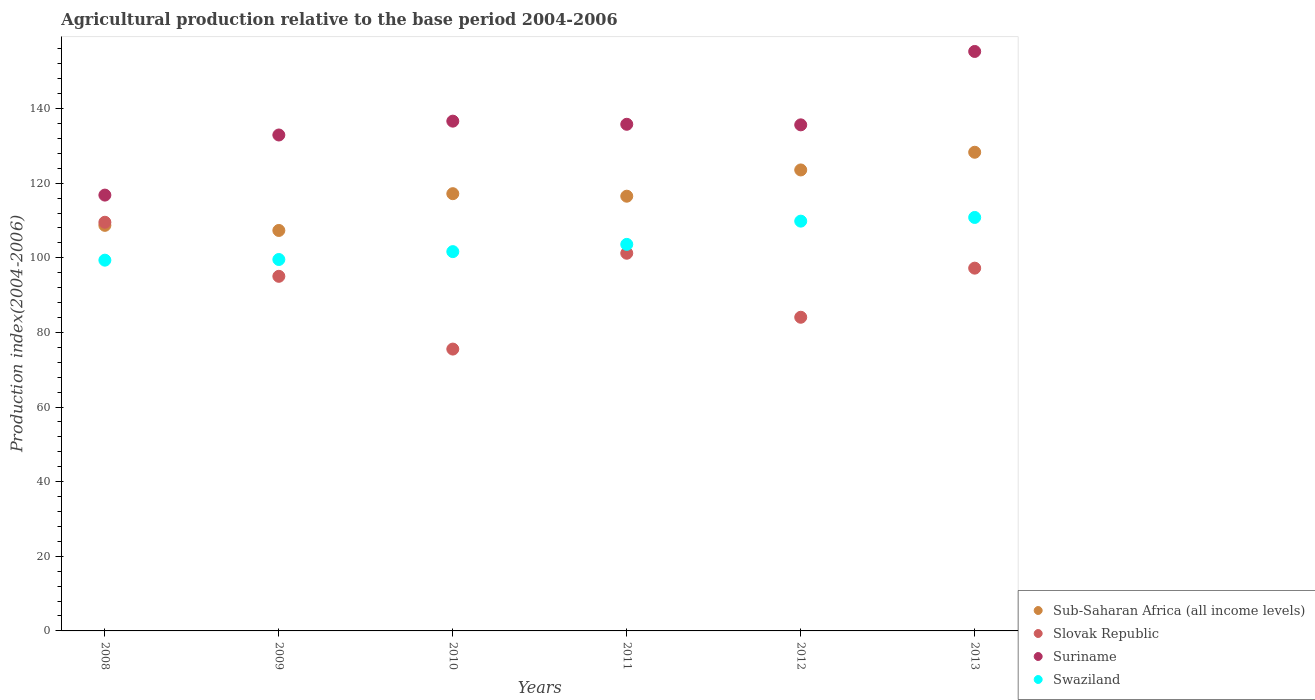How many different coloured dotlines are there?
Provide a succinct answer. 4. What is the agricultural production index in Sub-Saharan Africa (all income levels) in 2011?
Ensure brevity in your answer.  116.52. Across all years, what is the maximum agricultural production index in Slovak Republic?
Your answer should be compact. 109.53. Across all years, what is the minimum agricultural production index in Slovak Republic?
Offer a very short reply. 75.54. What is the total agricultural production index in Swaziland in the graph?
Keep it short and to the point. 624.83. What is the difference between the agricultural production index in Suriname in 2012 and that in 2013?
Make the answer very short. -19.67. What is the difference between the agricultural production index in Sub-Saharan Africa (all income levels) in 2010 and the agricultural production index in Swaziland in 2009?
Offer a terse response. 17.64. What is the average agricultural production index in Swaziland per year?
Make the answer very short. 104.14. In the year 2010, what is the difference between the agricultural production index in Slovak Republic and agricultural production index in Suriname?
Provide a succinct answer. -61.09. In how many years, is the agricultural production index in Suriname greater than 32?
Provide a succinct answer. 6. What is the ratio of the agricultural production index in Sub-Saharan Africa (all income levels) in 2009 to that in 2012?
Provide a succinct answer. 0.87. Is the difference between the agricultural production index in Slovak Republic in 2011 and 2012 greater than the difference between the agricultural production index in Suriname in 2011 and 2012?
Make the answer very short. Yes. What is the difference between the highest and the second highest agricultural production index in Slovak Republic?
Keep it short and to the point. 8.3. What is the difference between the highest and the lowest agricultural production index in Suriname?
Give a very brief answer. 38.5. In how many years, is the agricultural production index in Swaziland greater than the average agricultural production index in Swaziland taken over all years?
Offer a very short reply. 2. Is the sum of the agricultural production index in Suriname in 2008 and 2009 greater than the maximum agricultural production index in Sub-Saharan Africa (all income levels) across all years?
Provide a short and direct response. Yes. Does the agricultural production index in Slovak Republic monotonically increase over the years?
Ensure brevity in your answer.  No. How many dotlines are there?
Your answer should be compact. 4. What is the difference between two consecutive major ticks on the Y-axis?
Provide a succinct answer. 20. Are the values on the major ticks of Y-axis written in scientific E-notation?
Give a very brief answer. No. Does the graph contain any zero values?
Offer a terse response. No. Does the graph contain grids?
Your response must be concise. No. Where does the legend appear in the graph?
Offer a terse response. Bottom right. What is the title of the graph?
Provide a succinct answer. Agricultural production relative to the base period 2004-2006. Does "Saudi Arabia" appear as one of the legend labels in the graph?
Keep it short and to the point. No. What is the label or title of the X-axis?
Make the answer very short. Years. What is the label or title of the Y-axis?
Your answer should be compact. Production index(2004-2006). What is the Production index(2004-2006) in Sub-Saharan Africa (all income levels) in 2008?
Your answer should be very brief. 108.7. What is the Production index(2004-2006) of Slovak Republic in 2008?
Provide a succinct answer. 109.53. What is the Production index(2004-2006) of Suriname in 2008?
Provide a succinct answer. 116.81. What is the Production index(2004-2006) of Swaziland in 2008?
Your response must be concise. 99.37. What is the Production index(2004-2006) in Sub-Saharan Africa (all income levels) in 2009?
Make the answer very short. 107.33. What is the Production index(2004-2006) in Slovak Republic in 2009?
Your answer should be compact. 95.04. What is the Production index(2004-2006) of Suriname in 2009?
Keep it short and to the point. 132.92. What is the Production index(2004-2006) of Swaziland in 2009?
Offer a terse response. 99.55. What is the Production index(2004-2006) of Sub-Saharan Africa (all income levels) in 2010?
Offer a very short reply. 117.19. What is the Production index(2004-2006) of Slovak Republic in 2010?
Your answer should be compact. 75.54. What is the Production index(2004-2006) in Suriname in 2010?
Offer a very short reply. 136.63. What is the Production index(2004-2006) of Swaziland in 2010?
Offer a terse response. 101.66. What is the Production index(2004-2006) of Sub-Saharan Africa (all income levels) in 2011?
Keep it short and to the point. 116.52. What is the Production index(2004-2006) of Slovak Republic in 2011?
Offer a very short reply. 101.23. What is the Production index(2004-2006) in Suriname in 2011?
Your answer should be compact. 135.79. What is the Production index(2004-2006) in Swaziland in 2011?
Provide a short and direct response. 103.6. What is the Production index(2004-2006) of Sub-Saharan Africa (all income levels) in 2012?
Ensure brevity in your answer.  123.55. What is the Production index(2004-2006) in Slovak Republic in 2012?
Your answer should be compact. 84.07. What is the Production index(2004-2006) in Suriname in 2012?
Your response must be concise. 135.64. What is the Production index(2004-2006) in Swaziland in 2012?
Offer a very short reply. 109.83. What is the Production index(2004-2006) of Sub-Saharan Africa (all income levels) in 2013?
Your answer should be compact. 128.29. What is the Production index(2004-2006) in Slovak Republic in 2013?
Offer a terse response. 97.23. What is the Production index(2004-2006) of Suriname in 2013?
Keep it short and to the point. 155.31. What is the Production index(2004-2006) of Swaziland in 2013?
Provide a short and direct response. 110.82. Across all years, what is the maximum Production index(2004-2006) in Sub-Saharan Africa (all income levels)?
Provide a succinct answer. 128.29. Across all years, what is the maximum Production index(2004-2006) of Slovak Republic?
Make the answer very short. 109.53. Across all years, what is the maximum Production index(2004-2006) of Suriname?
Provide a short and direct response. 155.31. Across all years, what is the maximum Production index(2004-2006) in Swaziland?
Provide a succinct answer. 110.82. Across all years, what is the minimum Production index(2004-2006) of Sub-Saharan Africa (all income levels)?
Offer a terse response. 107.33. Across all years, what is the minimum Production index(2004-2006) in Slovak Republic?
Your answer should be compact. 75.54. Across all years, what is the minimum Production index(2004-2006) of Suriname?
Your response must be concise. 116.81. Across all years, what is the minimum Production index(2004-2006) in Swaziland?
Offer a terse response. 99.37. What is the total Production index(2004-2006) in Sub-Saharan Africa (all income levels) in the graph?
Your answer should be compact. 701.59. What is the total Production index(2004-2006) in Slovak Republic in the graph?
Your response must be concise. 562.64. What is the total Production index(2004-2006) in Suriname in the graph?
Give a very brief answer. 813.1. What is the total Production index(2004-2006) in Swaziland in the graph?
Offer a terse response. 624.83. What is the difference between the Production index(2004-2006) of Sub-Saharan Africa (all income levels) in 2008 and that in 2009?
Your answer should be very brief. 1.37. What is the difference between the Production index(2004-2006) in Slovak Republic in 2008 and that in 2009?
Offer a terse response. 14.49. What is the difference between the Production index(2004-2006) of Suriname in 2008 and that in 2009?
Your response must be concise. -16.11. What is the difference between the Production index(2004-2006) in Swaziland in 2008 and that in 2009?
Provide a succinct answer. -0.18. What is the difference between the Production index(2004-2006) of Sub-Saharan Africa (all income levels) in 2008 and that in 2010?
Your answer should be compact. -8.49. What is the difference between the Production index(2004-2006) of Slovak Republic in 2008 and that in 2010?
Provide a succinct answer. 33.99. What is the difference between the Production index(2004-2006) of Suriname in 2008 and that in 2010?
Give a very brief answer. -19.82. What is the difference between the Production index(2004-2006) in Swaziland in 2008 and that in 2010?
Offer a very short reply. -2.29. What is the difference between the Production index(2004-2006) in Sub-Saharan Africa (all income levels) in 2008 and that in 2011?
Your answer should be very brief. -7.81. What is the difference between the Production index(2004-2006) of Suriname in 2008 and that in 2011?
Your answer should be very brief. -18.98. What is the difference between the Production index(2004-2006) of Swaziland in 2008 and that in 2011?
Keep it short and to the point. -4.23. What is the difference between the Production index(2004-2006) of Sub-Saharan Africa (all income levels) in 2008 and that in 2012?
Your response must be concise. -14.85. What is the difference between the Production index(2004-2006) in Slovak Republic in 2008 and that in 2012?
Your answer should be compact. 25.46. What is the difference between the Production index(2004-2006) in Suriname in 2008 and that in 2012?
Provide a succinct answer. -18.83. What is the difference between the Production index(2004-2006) of Swaziland in 2008 and that in 2012?
Make the answer very short. -10.46. What is the difference between the Production index(2004-2006) in Sub-Saharan Africa (all income levels) in 2008 and that in 2013?
Offer a very short reply. -19.59. What is the difference between the Production index(2004-2006) of Slovak Republic in 2008 and that in 2013?
Offer a terse response. 12.3. What is the difference between the Production index(2004-2006) in Suriname in 2008 and that in 2013?
Keep it short and to the point. -38.5. What is the difference between the Production index(2004-2006) in Swaziland in 2008 and that in 2013?
Make the answer very short. -11.45. What is the difference between the Production index(2004-2006) of Sub-Saharan Africa (all income levels) in 2009 and that in 2010?
Ensure brevity in your answer.  -9.86. What is the difference between the Production index(2004-2006) in Slovak Republic in 2009 and that in 2010?
Keep it short and to the point. 19.5. What is the difference between the Production index(2004-2006) in Suriname in 2009 and that in 2010?
Offer a very short reply. -3.71. What is the difference between the Production index(2004-2006) in Swaziland in 2009 and that in 2010?
Provide a short and direct response. -2.11. What is the difference between the Production index(2004-2006) in Sub-Saharan Africa (all income levels) in 2009 and that in 2011?
Your answer should be compact. -9.18. What is the difference between the Production index(2004-2006) of Slovak Republic in 2009 and that in 2011?
Provide a short and direct response. -6.19. What is the difference between the Production index(2004-2006) in Suriname in 2009 and that in 2011?
Your answer should be very brief. -2.87. What is the difference between the Production index(2004-2006) of Swaziland in 2009 and that in 2011?
Offer a very short reply. -4.05. What is the difference between the Production index(2004-2006) in Sub-Saharan Africa (all income levels) in 2009 and that in 2012?
Your response must be concise. -16.22. What is the difference between the Production index(2004-2006) in Slovak Republic in 2009 and that in 2012?
Keep it short and to the point. 10.97. What is the difference between the Production index(2004-2006) in Suriname in 2009 and that in 2012?
Ensure brevity in your answer.  -2.72. What is the difference between the Production index(2004-2006) of Swaziland in 2009 and that in 2012?
Ensure brevity in your answer.  -10.28. What is the difference between the Production index(2004-2006) in Sub-Saharan Africa (all income levels) in 2009 and that in 2013?
Ensure brevity in your answer.  -20.96. What is the difference between the Production index(2004-2006) of Slovak Republic in 2009 and that in 2013?
Make the answer very short. -2.19. What is the difference between the Production index(2004-2006) of Suriname in 2009 and that in 2013?
Give a very brief answer. -22.39. What is the difference between the Production index(2004-2006) of Swaziland in 2009 and that in 2013?
Your answer should be compact. -11.27. What is the difference between the Production index(2004-2006) in Sub-Saharan Africa (all income levels) in 2010 and that in 2011?
Provide a succinct answer. 0.67. What is the difference between the Production index(2004-2006) of Slovak Republic in 2010 and that in 2011?
Offer a terse response. -25.69. What is the difference between the Production index(2004-2006) of Suriname in 2010 and that in 2011?
Make the answer very short. 0.84. What is the difference between the Production index(2004-2006) of Swaziland in 2010 and that in 2011?
Your response must be concise. -1.94. What is the difference between the Production index(2004-2006) in Sub-Saharan Africa (all income levels) in 2010 and that in 2012?
Ensure brevity in your answer.  -6.36. What is the difference between the Production index(2004-2006) in Slovak Republic in 2010 and that in 2012?
Provide a short and direct response. -8.53. What is the difference between the Production index(2004-2006) in Swaziland in 2010 and that in 2012?
Provide a succinct answer. -8.17. What is the difference between the Production index(2004-2006) in Sub-Saharan Africa (all income levels) in 2010 and that in 2013?
Your response must be concise. -11.1. What is the difference between the Production index(2004-2006) of Slovak Republic in 2010 and that in 2013?
Provide a succinct answer. -21.69. What is the difference between the Production index(2004-2006) of Suriname in 2010 and that in 2013?
Provide a short and direct response. -18.68. What is the difference between the Production index(2004-2006) of Swaziland in 2010 and that in 2013?
Make the answer very short. -9.16. What is the difference between the Production index(2004-2006) of Sub-Saharan Africa (all income levels) in 2011 and that in 2012?
Your answer should be compact. -7.04. What is the difference between the Production index(2004-2006) of Slovak Republic in 2011 and that in 2012?
Give a very brief answer. 17.16. What is the difference between the Production index(2004-2006) of Swaziland in 2011 and that in 2012?
Provide a short and direct response. -6.23. What is the difference between the Production index(2004-2006) of Sub-Saharan Africa (all income levels) in 2011 and that in 2013?
Offer a terse response. -11.78. What is the difference between the Production index(2004-2006) in Suriname in 2011 and that in 2013?
Offer a very short reply. -19.52. What is the difference between the Production index(2004-2006) in Swaziland in 2011 and that in 2013?
Provide a short and direct response. -7.22. What is the difference between the Production index(2004-2006) in Sub-Saharan Africa (all income levels) in 2012 and that in 2013?
Your answer should be very brief. -4.74. What is the difference between the Production index(2004-2006) in Slovak Republic in 2012 and that in 2013?
Ensure brevity in your answer.  -13.16. What is the difference between the Production index(2004-2006) in Suriname in 2012 and that in 2013?
Provide a short and direct response. -19.67. What is the difference between the Production index(2004-2006) of Swaziland in 2012 and that in 2013?
Your answer should be compact. -0.99. What is the difference between the Production index(2004-2006) in Sub-Saharan Africa (all income levels) in 2008 and the Production index(2004-2006) in Slovak Republic in 2009?
Your answer should be very brief. 13.66. What is the difference between the Production index(2004-2006) in Sub-Saharan Africa (all income levels) in 2008 and the Production index(2004-2006) in Suriname in 2009?
Keep it short and to the point. -24.22. What is the difference between the Production index(2004-2006) in Sub-Saharan Africa (all income levels) in 2008 and the Production index(2004-2006) in Swaziland in 2009?
Offer a terse response. 9.15. What is the difference between the Production index(2004-2006) in Slovak Republic in 2008 and the Production index(2004-2006) in Suriname in 2009?
Your answer should be very brief. -23.39. What is the difference between the Production index(2004-2006) in Slovak Republic in 2008 and the Production index(2004-2006) in Swaziland in 2009?
Make the answer very short. 9.98. What is the difference between the Production index(2004-2006) of Suriname in 2008 and the Production index(2004-2006) of Swaziland in 2009?
Offer a terse response. 17.26. What is the difference between the Production index(2004-2006) of Sub-Saharan Africa (all income levels) in 2008 and the Production index(2004-2006) of Slovak Republic in 2010?
Keep it short and to the point. 33.16. What is the difference between the Production index(2004-2006) of Sub-Saharan Africa (all income levels) in 2008 and the Production index(2004-2006) of Suriname in 2010?
Offer a very short reply. -27.93. What is the difference between the Production index(2004-2006) of Sub-Saharan Africa (all income levels) in 2008 and the Production index(2004-2006) of Swaziland in 2010?
Provide a succinct answer. 7.04. What is the difference between the Production index(2004-2006) in Slovak Republic in 2008 and the Production index(2004-2006) in Suriname in 2010?
Your response must be concise. -27.1. What is the difference between the Production index(2004-2006) of Slovak Republic in 2008 and the Production index(2004-2006) of Swaziland in 2010?
Offer a terse response. 7.87. What is the difference between the Production index(2004-2006) in Suriname in 2008 and the Production index(2004-2006) in Swaziland in 2010?
Your response must be concise. 15.15. What is the difference between the Production index(2004-2006) in Sub-Saharan Africa (all income levels) in 2008 and the Production index(2004-2006) in Slovak Republic in 2011?
Offer a very short reply. 7.47. What is the difference between the Production index(2004-2006) in Sub-Saharan Africa (all income levels) in 2008 and the Production index(2004-2006) in Suriname in 2011?
Provide a succinct answer. -27.09. What is the difference between the Production index(2004-2006) of Sub-Saharan Africa (all income levels) in 2008 and the Production index(2004-2006) of Swaziland in 2011?
Make the answer very short. 5.1. What is the difference between the Production index(2004-2006) of Slovak Republic in 2008 and the Production index(2004-2006) of Suriname in 2011?
Your response must be concise. -26.26. What is the difference between the Production index(2004-2006) in Slovak Republic in 2008 and the Production index(2004-2006) in Swaziland in 2011?
Your answer should be compact. 5.93. What is the difference between the Production index(2004-2006) of Suriname in 2008 and the Production index(2004-2006) of Swaziland in 2011?
Offer a terse response. 13.21. What is the difference between the Production index(2004-2006) of Sub-Saharan Africa (all income levels) in 2008 and the Production index(2004-2006) of Slovak Republic in 2012?
Make the answer very short. 24.63. What is the difference between the Production index(2004-2006) in Sub-Saharan Africa (all income levels) in 2008 and the Production index(2004-2006) in Suriname in 2012?
Keep it short and to the point. -26.94. What is the difference between the Production index(2004-2006) of Sub-Saharan Africa (all income levels) in 2008 and the Production index(2004-2006) of Swaziland in 2012?
Keep it short and to the point. -1.13. What is the difference between the Production index(2004-2006) in Slovak Republic in 2008 and the Production index(2004-2006) in Suriname in 2012?
Offer a very short reply. -26.11. What is the difference between the Production index(2004-2006) in Suriname in 2008 and the Production index(2004-2006) in Swaziland in 2012?
Your answer should be compact. 6.98. What is the difference between the Production index(2004-2006) of Sub-Saharan Africa (all income levels) in 2008 and the Production index(2004-2006) of Slovak Republic in 2013?
Your response must be concise. 11.47. What is the difference between the Production index(2004-2006) in Sub-Saharan Africa (all income levels) in 2008 and the Production index(2004-2006) in Suriname in 2013?
Offer a terse response. -46.61. What is the difference between the Production index(2004-2006) of Sub-Saharan Africa (all income levels) in 2008 and the Production index(2004-2006) of Swaziland in 2013?
Your answer should be very brief. -2.12. What is the difference between the Production index(2004-2006) in Slovak Republic in 2008 and the Production index(2004-2006) in Suriname in 2013?
Provide a succinct answer. -45.78. What is the difference between the Production index(2004-2006) of Slovak Republic in 2008 and the Production index(2004-2006) of Swaziland in 2013?
Keep it short and to the point. -1.29. What is the difference between the Production index(2004-2006) of Suriname in 2008 and the Production index(2004-2006) of Swaziland in 2013?
Your answer should be compact. 5.99. What is the difference between the Production index(2004-2006) of Sub-Saharan Africa (all income levels) in 2009 and the Production index(2004-2006) of Slovak Republic in 2010?
Ensure brevity in your answer.  31.79. What is the difference between the Production index(2004-2006) in Sub-Saharan Africa (all income levels) in 2009 and the Production index(2004-2006) in Suriname in 2010?
Your response must be concise. -29.3. What is the difference between the Production index(2004-2006) in Sub-Saharan Africa (all income levels) in 2009 and the Production index(2004-2006) in Swaziland in 2010?
Provide a short and direct response. 5.67. What is the difference between the Production index(2004-2006) in Slovak Republic in 2009 and the Production index(2004-2006) in Suriname in 2010?
Give a very brief answer. -41.59. What is the difference between the Production index(2004-2006) in Slovak Republic in 2009 and the Production index(2004-2006) in Swaziland in 2010?
Give a very brief answer. -6.62. What is the difference between the Production index(2004-2006) of Suriname in 2009 and the Production index(2004-2006) of Swaziland in 2010?
Keep it short and to the point. 31.26. What is the difference between the Production index(2004-2006) in Sub-Saharan Africa (all income levels) in 2009 and the Production index(2004-2006) in Slovak Republic in 2011?
Keep it short and to the point. 6.1. What is the difference between the Production index(2004-2006) of Sub-Saharan Africa (all income levels) in 2009 and the Production index(2004-2006) of Suriname in 2011?
Keep it short and to the point. -28.46. What is the difference between the Production index(2004-2006) of Sub-Saharan Africa (all income levels) in 2009 and the Production index(2004-2006) of Swaziland in 2011?
Your answer should be very brief. 3.73. What is the difference between the Production index(2004-2006) in Slovak Republic in 2009 and the Production index(2004-2006) in Suriname in 2011?
Keep it short and to the point. -40.75. What is the difference between the Production index(2004-2006) in Slovak Republic in 2009 and the Production index(2004-2006) in Swaziland in 2011?
Your answer should be compact. -8.56. What is the difference between the Production index(2004-2006) in Suriname in 2009 and the Production index(2004-2006) in Swaziland in 2011?
Your answer should be compact. 29.32. What is the difference between the Production index(2004-2006) in Sub-Saharan Africa (all income levels) in 2009 and the Production index(2004-2006) in Slovak Republic in 2012?
Your answer should be very brief. 23.26. What is the difference between the Production index(2004-2006) in Sub-Saharan Africa (all income levels) in 2009 and the Production index(2004-2006) in Suriname in 2012?
Your answer should be compact. -28.31. What is the difference between the Production index(2004-2006) of Sub-Saharan Africa (all income levels) in 2009 and the Production index(2004-2006) of Swaziland in 2012?
Keep it short and to the point. -2.5. What is the difference between the Production index(2004-2006) in Slovak Republic in 2009 and the Production index(2004-2006) in Suriname in 2012?
Offer a terse response. -40.6. What is the difference between the Production index(2004-2006) in Slovak Republic in 2009 and the Production index(2004-2006) in Swaziland in 2012?
Your answer should be compact. -14.79. What is the difference between the Production index(2004-2006) of Suriname in 2009 and the Production index(2004-2006) of Swaziland in 2012?
Offer a very short reply. 23.09. What is the difference between the Production index(2004-2006) in Sub-Saharan Africa (all income levels) in 2009 and the Production index(2004-2006) in Slovak Republic in 2013?
Keep it short and to the point. 10.1. What is the difference between the Production index(2004-2006) in Sub-Saharan Africa (all income levels) in 2009 and the Production index(2004-2006) in Suriname in 2013?
Your answer should be compact. -47.98. What is the difference between the Production index(2004-2006) of Sub-Saharan Africa (all income levels) in 2009 and the Production index(2004-2006) of Swaziland in 2013?
Your response must be concise. -3.49. What is the difference between the Production index(2004-2006) of Slovak Republic in 2009 and the Production index(2004-2006) of Suriname in 2013?
Provide a succinct answer. -60.27. What is the difference between the Production index(2004-2006) of Slovak Republic in 2009 and the Production index(2004-2006) of Swaziland in 2013?
Keep it short and to the point. -15.78. What is the difference between the Production index(2004-2006) of Suriname in 2009 and the Production index(2004-2006) of Swaziland in 2013?
Your answer should be very brief. 22.1. What is the difference between the Production index(2004-2006) in Sub-Saharan Africa (all income levels) in 2010 and the Production index(2004-2006) in Slovak Republic in 2011?
Give a very brief answer. 15.96. What is the difference between the Production index(2004-2006) in Sub-Saharan Africa (all income levels) in 2010 and the Production index(2004-2006) in Suriname in 2011?
Your answer should be compact. -18.6. What is the difference between the Production index(2004-2006) in Sub-Saharan Africa (all income levels) in 2010 and the Production index(2004-2006) in Swaziland in 2011?
Your answer should be compact. 13.59. What is the difference between the Production index(2004-2006) of Slovak Republic in 2010 and the Production index(2004-2006) of Suriname in 2011?
Offer a very short reply. -60.25. What is the difference between the Production index(2004-2006) of Slovak Republic in 2010 and the Production index(2004-2006) of Swaziland in 2011?
Your answer should be very brief. -28.06. What is the difference between the Production index(2004-2006) in Suriname in 2010 and the Production index(2004-2006) in Swaziland in 2011?
Provide a short and direct response. 33.03. What is the difference between the Production index(2004-2006) in Sub-Saharan Africa (all income levels) in 2010 and the Production index(2004-2006) in Slovak Republic in 2012?
Your response must be concise. 33.12. What is the difference between the Production index(2004-2006) of Sub-Saharan Africa (all income levels) in 2010 and the Production index(2004-2006) of Suriname in 2012?
Your answer should be compact. -18.45. What is the difference between the Production index(2004-2006) in Sub-Saharan Africa (all income levels) in 2010 and the Production index(2004-2006) in Swaziland in 2012?
Provide a short and direct response. 7.36. What is the difference between the Production index(2004-2006) of Slovak Republic in 2010 and the Production index(2004-2006) of Suriname in 2012?
Your answer should be very brief. -60.1. What is the difference between the Production index(2004-2006) of Slovak Republic in 2010 and the Production index(2004-2006) of Swaziland in 2012?
Offer a very short reply. -34.29. What is the difference between the Production index(2004-2006) of Suriname in 2010 and the Production index(2004-2006) of Swaziland in 2012?
Keep it short and to the point. 26.8. What is the difference between the Production index(2004-2006) of Sub-Saharan Africa (all income levels) in 2010 and the Production index(2004-2006) of Slovak Republic in 2013?
Keep it short and to the point. 19.96. What is the difference between the Production index(2004-2006) in Sub-Saharan Africa (all income levels) in 2010 and the Production index(2004-2006) in Suriname in 2013?
Your answer should be very brief. -38.12. What is the difference between the Production index(2004-2006) of Sub-Saharan Africa (all income levels) in 2010 and the Production index(2004-2006) of Swaziland in 2013?
Your answer should be compact. 6.37. What is the difference between the Production index(2004-2006) in Slovak Republic in 2010 and the Production index(2004-2006) in Suriname in 2013?
Make the answer very short. -79.77. What is the difference between the Production index(2004-2006) in Slovak Republic in 2010 and the Production index(2004-2006) in Swaziland in 2013?
Your answer should be compact. -35.28. What is the difference between the Production index(2004-2006) in Suriname in 2010 and the Production index(2004-2006) in Swaziland in 2013?
Your response must be concise. 25.81. What is the difference between the Production index(2004-2006) in Sub-Saharan Africa (all income levels) in 2011 and the Production index(2004-2006) in Slovak Republic in 2012?
Provide a short and direct response. 32.45. What is the difference between the Production index(2004-2006) of Sub-Saharan Africa (all income levels) in 2011 and the Production index(2004-2006) of Suriname in 2012?
Offer a very short reply. -19.12. What is the difference between the Production index(2004-2006) of Sub-Saharan Africa (all income levels) in 2011 and the Production index(2004-2006) of Swaziland in 2012?
Keep it short and to the point. 6.69. What is the difference between the Production index(2004-2006) of Slovak Republic in 2011 and the Production index(2004-2006) of Suriname in 2012?
Provide a short and direct response. -34.41. What is the difference between the Production index(2004-2006) of Slovak Republic in 2011 and the Production index(2004-2006) of Swaziland in 2012?
Provide a succinct answer. -8.6. What is the difference between the Production index(2004-2006) of Suriname in 2011 and the Production index(2004-2006) of Swaziland in 2012?
Give a very brief answer. 25.96. What is the difference between the Production index(2004-2006) in Sub-Saharan Africa (all income levels) in 2011 and the Production index(2004-2006) in Slovak Republic in 2013?
Your answer should be very brief. 19.29. What is the difference between the Production index(2004-2006) in Sub-Saharan Africa (all income levels) in 2011 and the Production index(2004-2006) in Suriname in 2013?
Offer a very short reply. -38.79. What is the difference between the Production index(2004-2006) in Sub-Saharan Africa (all income levels) in 2011 and the Production index(2004-2006) in Swaziland in 2013?
Ensure brevity in your answer.  5.7. What is the difference between the Production index(2004-2006) in Slovak Republic in 2011 and the Production index(2004-2006) in Suriname in 2013?
Make the answer very short. -54.08. What is the difference between the Production index(2004-2006) in Slovak Republic in 2011 and the Production index(2004-2006) in Swaziland in 2013?
Provide a short and direct response. -9.59. What is the difference between the Production index(2004-2006) of Suriname in 2011 and the Production index(2004-2006) of Swaziland in 2013?
Provide a succinct answer. 24.97. What is the difference between the Production index(2004-2006) in Sub-Saharan Africa (all income levels) in 2012 and the Production index(2004-2006) in Slovak Republic in 2013?
Your response must be concise. 26.32. What is the difference between the Production index(2004-2006) of Sub-Saharan Africa (all income levels) in 2012 and the Production index(2004-2006) of Suriname in 2013?
Give a very brief answer. -31.76. What is the difference between the Production index(2004-2006) of Sub-Saharan Africa (all income levels) in 2012 and the Production index(2004-2006) of Swaziland in 2013?
Your answer should be very brief. 12.73. What is the difference between the Production index(2004-2006) in Slovak Republic in 2012 and the Production index(2004-2006) in Suriname in 2013?
Provide a succinct answer. -71.24. What is the difference between the Production index(2004-2006) in Slovak Republic in 2012 and the Production index(2004-2006) in Swaziland in 2013?
Make the answer very short. -26.75. What is the difference between the Production index(2004-2006) of Suriname in 2012 and the Production index(2004-2006) of Swaziland in 2013?
Offer a very short reply. 24.82. What is the average Production index(2004-2006) of Sub-Saharan Africa (all income levels) per year?
Provide a succinct answer. 116.93. What is the average Production index(2004-2006) of Slovak Republic per year?
Provide a short and direct response. 93.77. What is the average Production index(2004-2006) of Suriname per year?
Provide a short and direct response. 135.52. What is the average Production index(2004-2006) of Swaziland per year?
Offer a terse response. 104.14. In the year 2008, what is the difference between the Production index(2004-2006) of Sub-Saharan Africa (all income levels) and Production index(2004-2006) of Slovak Republic?
Provide a succinct answer. -0.83. In the year 2008, what is the difference between the Production index(2004-2006) of Sub-Saharan Africa (all income levels) and Production index(2004-2006) of Suriname?
Your response must be concise. -8.11. In the year 2008, what is the difference between the Production index(2004-2006) of Sub-Saharan Africa (all income levels) and Production index(2004-2006) of Swaziland?
Keep it short and to the point. 9.33. In the year 2008, what is the difference between the Production index(2004-2006) of Slovak Republic and Production index(2004-2006) of Suriname?
Make the answer very short. -7.28. In the year 2008, what is the difference between the Production index(2004-2006) in Slovak Republic and Production index(2004-2006) in Swaziland?
Ensure brevity in your answer.  10.16. In the year 2008, what is the difference between the Production index(2004-2006) of Suriname and Production index(2004-2006) of Swaziland?
Ensure brevity in your answer.  17.44. In the year 2009, what is the difference between the Production index(2004-2006) in Sub-Saharan Africa (all income levels) and Production index(2004-2006) in Slovak Republic?
Provide a succinct answer. 12.29. In the year 2009, what is the difference between the Production index(2004-2006) in Sub-Saharan Africa (all income levels) and Production index(2004-2006) in Suriname?
Offer a terse response. -25.59. In the year 2009, what is the difference between the Production index(2004-2006) of Sub-Saharan Africa (all income levels) and Production index(2004-2006) of Swaziland?
Ensure brevity in your answer.  7.78. In the year 2009, what is the difference between the Production index(2004-2006) of Slovak Republic and Production index(2004-2006) of Suriname?
Provide a short and direct response. -37.88. In the year 2009, what is the difference between the Production index(2004-2006) in Slovak Republic and Production index(2004-2006) in Swaziland?
Give a very brief answer. -4.51. In the year 2009, what is the difference between the Production index(2004-2006) of Suriname and Production index(2004-2006) of Swaziland?
Your answer should be very brief. 33.37. In the year 2010, what is the difference between the Production index(2004-2006) of Sub-Saharan Africa (all income levels) and Production index(2004-2006) of Slovak Republic?
Your answer should be very brief. 41.65. In the year 2010, what is the difference between the Production index(2004-2006) in Sub-Saharan Africa (all income levels) and Production index(2004-2006) in Suriname?
Provide a short and direct response. -19.44. In the year 2010, what is the difference between the Production index(2004-2006) in Sub-Saharan Africa (all income levels) and Production index(2004-2006) in Swaziland?
Make the answer very short. 15.53. In the year 2010, what is the difference between the Production index(2004-2006) of Slovak Republic and Production index(2004-2006) of Suriname?
Your answer should be very brief. -61.09. In the year 2010, what is the difference between the Production index(2004-2006) in Slovak Republic and Production index(2004-2006) in Swaziland?
Provide a short and direct response. -26.12. In the year 2010, what is the difference between the Production index(2004-2006) of Suriname and Production index(2004-2006) of Swaziland?
Give a very brief answer. 34.97. In the year 2011, what is the difference between the Production index(2004-2006) in Sub-Saharan Africa (all income levels) and Production index(2004-2006) in Slovak Republic?
Keep it short and to the point. 15.29. In the year 2011, what is the difference between the Production index(2004-2006) in Sub-Saharan Africa (all income levels) and Production index(2004-2006) in Suriname?
Offer a very short reply. -19.27. In the year 2011, what is the difference between the Production index(2004-2006) in Sub-Saharan Africa (all income levels) and Production index(2004-2006) in Swaziland?
Make the answer very short. 12.92. In the year 2011, what is the difference between the Production index(2004-2006) of Slovak Republic and Production index(2004-2006) of Suriname?
Make the answer very short. -34.56. In the year 2011, what is the difference between the Production index(2004-2006) of Slovak Republic and Production index(2004-2006) of Swaziland?
Offer a terse response. -2.37. In the year 2011, what is the difference between the Production index(2004-2006) in Suriname and Production index(2004-2006) in Swaziland?
Your answer should be very brief. 32.19. In the year 2012, what is the difference between the Production index(2004-2006) of Sub-Saharan Africa (all income levels) and Production index(2004-2006) of Slovak Republic?
Provide a short and direct response. 39.48. In the year 2012, what is the difference between the Production index(2004-2006) in Sub-Saharan Africa (all income levels) and Production index(2004-2006) in Suriname?
Provide a short and direct response. -12.09. In the year 2012, what is the difference between the Production index(2004-2006) of Sub-Saharan Africa (all income levels) and Production index(2004-2006) of Swaziland?
Offer a terse response. 13.72. In the year 2012, what is the difference between the Production index(2004-2006) of Slovak Republic and Production index(2004-2006) of Suriname?
Keep it short and to the point. -51.57. In the year 2012, what is the difference between the Production index(2004-2006) in Slovak Republic and Production index(2004-2006) in Swaziland?
Give a very brief answer. -25.76. In the year 2012, what is the difference between the Production index(2004-2006) of Suriname and Production index(2004-2006) of Swaziland?
Your response must be concise. 25.81. In the year 2013, what is the difference between the Production index(2004-2006) in Sub-Saharan Africa (all income levels) and Production index(2004-2006) in Slovak Republic?
Keep it short and to the point. 31.06. In the year 2013, what is the difference between the Production index(2004-2006) in Sub-Saharan Africa (all income levels) and Production index(2004-2006) in Suriname?
Offer a terse response. -27.02. In the year 2013, what is the difference between the Production index(2004-2006) of Sub-Saharan Africa (all income levels) and Production index(2004-2006) of Swaziland?
Your answer should be very brief. 17.47. In the year 2013, what is the difference between the Production index(2004-2006) in Slovak Republic and Production index(2004-2006) in Suriname?
Provide a short and direct response. -58.08. In the year 2013, what is the difference between the Production index(2004-2006) of Slovak Republic and Production index(2004-2006) of Swaziland?
Provide a short and direct response. -13.59. In the year 2013, what is the difference between the Production index(2004-2006) in Suriname and Production index(2004-2006) in Swaziland?
Provide a succinct answer. 44.49. What is the ratio of the Production index(2004-2006) in Sub-Saharan Africa (all income levels) in 2008 to that in 2009?
Give a very brief answer. 1.01. What is the ratio of the Production index(2004-2006) of Slovak Republic in 2008 to that in 2009?
Provide a short and direct response. 1.15. What is the ratio of the Production index(2004-2006) of Suriname in 2008 to that in 2009?
Provide a short and direct response. 0.88. What is the ratio of the Production index(2004-2006) of Swaziland in 2008 to that in 2009?
Keep it short and to the point. 1. What is the ratio of the Production index(2004-2006) of Sub-Saharan Africa (all income levels) in 2008 to that in 2010?
Keep it short and to the point. 0.93. What is the ratio of the Production index(2004-2006) in Slovak Republic in 2008 to that in 2010?
Give a very brief answer. 1.45. What is the ratio of the Production index(2004-2006) of Suriname in 2008 to that in 2010?
Your response must be concise. 0.85. What is the ratio of the Production index(2004-2006) of Swaziland in 2008 to that in 2010?
Keep it short and to the point. 0.98. What is the ratio of the Production index(2004-2006) of Sub-Saharan Africa (all income levels) in 2008 to that in 2011?
Your answer should be very brief. 0.93. What is the ratio of the Production index(2004-2006) of Slovak Republic in 2008 to that in 2011?
Your response must be concise. 1.08. What is the ratio of the Production index(2004-2006) in Suriname in 2008 to that in 2011?
Your response must be concise. 0.86. What is the ratio of the Production index(2004-2006) of Swaziland in 2008 to that in 2011?
Ensure brevity in your answer.  0.96. What is the ratio of the Production index(2004-2006) in Sub-Saharan Africa (all income levels) in 2008 to that in 2012?
Provide a succinct answer. 0.88. What is the ratio of the Production index(2004-2006) of Slovak Republic in 2008 to that in 2012?
Provide a succinct answer. 1.3. What is the ratio of the Production index(2004-2006) of Suriname in 2008 to that in 2012?
Make the answer very short. 0.86. What is the ratio of the Production index(2004-2006) in Swaziland in 2008 to that in 2012?
Your answer should be compact. 0.9. What is the ratio of the Production index(2004-2006) of Sub-Saharan Africa (all income levels) in 2008 to that in 2013?
Keep it short and to the point. 0.85. What is the ratio of the Production index(2004-2006) in Slovak Republic in 2008 to that in 2013?
Offer a terse response. 1.13. What is the ratio of the Production index(2004-2006) in Suriname in 2008 to that in 2013?
Provide a short and direct response. 0.75. What is the ratio of the Production index(2004-2006) in Swaziland in 2008 to that in 2013?
Ensure brevity in your answer.  0.9. What is the ratio of the Production index(2004-2006) in Sub-Saharan Africa (all income levels) in 2009 to that in 2010?
Provide a succinct answer. 0.92. What is the ratio of the Production index(2004-2006) of Slovak Republic in 2009 to that in 2010?
Ensure brevity in your answer.  1.26. What is the ratio of the Production index(2004-2006) in Suriname in 2009 to that in 2010?
Offer a very short reply. 0.97. What is the ratio of the Production index(2004-2006) in Swaziland in 2009 to that in 2010?
Keep it short and to the point. 0.98. What is the ratio of the Production index(2004-2006) in Sub-Saharan Africa (all income levels) in 2009 to that in 2011?
Keep it short and to the point. 0.92. What is the ratio of the Production index(2004-2006) in Slovak Republic in 2009 to that in 2011?
Give a very brief answer. 0.94. What is the ratio of the Production index(2004-2006) in Suriname in 2009 to that in 2011?
Offer a very short reply. 0.98. What is the ratio of the Production index(2004-2006) in Swaziland in 2009 to that in 2011?
Your answer should be very brief. 0.96. What is the ratio of the Production index(2004-2006) in Sub-Saharan Africa (all income levels) in 2009 to that in 2012?
Provide a short and direct response. 0.87. What is the ratio of the Production index(2004-2006) of Slovak Republic in 2009 to that in 2012?
Your response must be concise. 1.13. What is the ratio of the Production index(2004-2006) in Suriname in 2009 to that in 2012?
Give a very brief answer. 0.98. What is the ratio of the Production index(2004-2006) in Swaziland in 2009 to that in 2012?
Provide a short and direct response. 0.91. What is the ratio of the Production index(2004-2006) in Sub-Saharan Africa (all income levels) in 2009 to that in 2013?
Your response must be concise. 0.84. What is the ratio of the Production index(2004-2006) in Slovak Republic in 2009 to that in 2013?
Your answer should be very brief. 0.98. What is the ratio of the Production index(2004-2006) of Suriname in 2009 to that in 2013?
Offer a very short reply. 0.86. What is the ratio of the Production index(2004-2006) of Swaziland in 2009 to that in 2013?
Ensure brevity in your answer.  0.9. What is the ratio of the Production index(2004-2006) in Sub-Saharan Africa (all income levels) in 2010 to that in 2011?
Make the answer very short. 1.01. What is the ratio of the Production index(2004-2006) of Slovak Republic in 2010 to that in 2011?
Your answer should be very brief. 0.75. What is the ratio of the Production index(2004-2006) in Swaziland in 2010 to that in 2011?
Offer a terse response. 0.98. What is the ratio of the Production index(2004-2006) of Sub-Saharan Africa (all income levels) in 2010 to that in 2012?
Ensure brevity in your answer.  0.95. What is the ratio of the Production index(2004-2006) of Slovak Republic in 2010 to that in 2012?
Your answer should be compact. 0.9. What is the ratio of the Production index(2004-2006) in Suriname in 2010 to that in 2012?
Provide a succinct answer. 1.01. What is the ratio of the Production index(2004-2006) of Swaziland in 2010 to that in 2012?
Offer a very short reply. 0.93. What is the ratio of the Production index(2004-2006) of Sub-Saharan Africa (all income levels) in 2010 to that in 2013?
Provide a succinct answer. 0.91. What is the ratio of the Production index(2004-2006) of Slovak Republic in 2010 to that in 2013?
Offer a very short reply. 0.78. What is the ratio of the Production index(2004-2006) in Suriname in 2010 to that in 2013?
Keep it short and to the point. 0.88. What is the ratio of the Production index(2004-2006) in Swaziland in 2010 to that in 2013?
Your answer should be very brief. 0.92. What is the ratio of the Production index(2004-2006) in Sub-Saharan Africa (all income levels) in 2011 to that in 2012?
Your response must be concise. 0.94. What is the ratio of the Production index(2004-2006) of Slovak Republic in 2011 to that in 2012?
Provide a short and direct response. 1.2. What is the ratio of the Production index(2004-2006) of Suriname in 2011 to that in 2012?
Give a very brief answer. 1. What is the ratio of the Production index(2004-2006) of Swaziland in 2011 to that in 2012?
Provide a succinct answer. 0.94. What is the ratio of the Production index(2004-2006) of Sub-Saharan Africa (all income levels) in 2011 to that in 2013?
Your answer should be very brief. 0.91. What is the ratio of the Production index(2004-2006) in Slovak Republic in 2011 to that in 2013?
Provide a succinct answer. 1.04. What is the ratio of the Production index(2004-2006) in Suriname in 2011 to that in 2013?
Offer a terse response. 0.87. What is the ratio of the Production index(2004-2006) of Swaziland in 2011 to that in 2013?
Give a very brief answer. 0.93. What is the ratio of the Production index(2004-2006) in Slovak Republic in 2012 to that in 2013?
Ensure brevity in your answer.  0.86. What is the ratio of the Production index(2004-2006) of Suriname in 2012 to that in 2013?
Keep it short and to the point. 0.87. What is the ratio of the Production index(2004-2006) in Swaziland in 2012 to that in 2013?
Ensure brevity in your answer.  0.99. What is the difference between the highest and the second highest Production index(2004-2006) of Sub-Saharan Africa (all income levels)?
Ensure brevity in your answer.  4.74. What is the difference between the highest and the second highest Production index(2004-2006) of Slovak Republic?
Your response must be concise. 8.3. What is the difference between the highest and the second highest Production index(2004-2006) in Suriname?
Your answer should be compact. 18.68. What is the difference between the highest and the second highest Production index(2004-2006) in Swaziland?
Your answer should be compact. 0.99. What is the difference between the highest and the lowest Production index(2004-2006) in Sub-Saharan Africa (all income levels)?
Make the answer very short. 20.96. What is the difference between the highest and the lowest Production index(2004-2006) in Slovak Republic?
Make the answer very short. 33.99. What is the difference between the highest and the lowest Production index(2004-2006) in Suriname?
Make the answer very short. 38.5. What is the difference between the highest and the lowest Production index(2004-2006) of Swaziland?
Offer a very short reply. 11.45. 